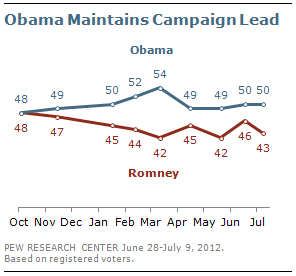Identify some key points in this picture. The minimum value for Romney is 42. The graph compares two leaders, and the two leaders being compared are Obama and Romney. 